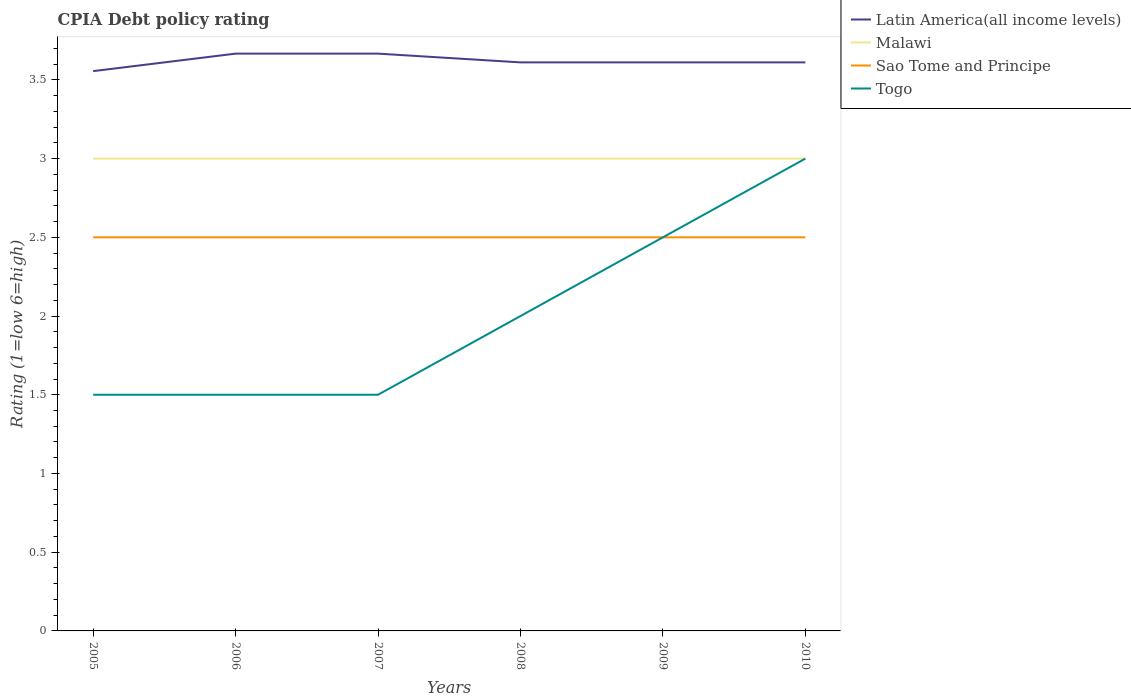Is the number of lines equal to the number of legend labels?
Provide a succinct answer. Yes. What is the total CPIA rating in Latin America(all income levels) in the graph?
Provide a short and direct response. -0.06. What is the difference between the highest and the lowest CPIA rating in Malawi?
Your answer should be compact. 0. Is the CPIA rating in Malawi strictly greater than the CPIA rating in Latin America(all income levels) over the years?
Make the answer very short. Yes. How many lines are there?
Make the answer very short. 4. How many years are there in the graph?
Provide a succinct answer. 6. What is the difference between two consecutive major ticks on the Y-axis?
Provide a short and direct response. 0.5. Are the values on the major ticks of Y-axis written in scientific E-notation?
Make the answer very short. No. Does the graph contain any zero values?
Keep it short and to the point. No. Does the graph contain grids?
Ensure brevity in your answer.  No. How many legend labels are there?
Provide a succinct answer. 4. How are the legend labels stacked?
Offer a very short reply. Vertical. What is the title of the graph?
Provide a short and direct response. CPIA Debt policy rating. What is the label or title of the Y-axis?
Provide a short and direct response. Rating (1=low 6=high). What is the Rating (1=low 6=high) of Latin America(all income levels) in 2005?
Give a very brief answer. 3.56. What is the Rating (1=low 6=high) in Sao Tome and Principe in 2005?
Offer a terse response. 2.5. What is the Rating (1=low 6=high) of Togo in 2005?
Offer a very short reply. 1.5. What is the Rating (1=low 6=high) of Latin America(all income levels) in 2006?
Provide a succinct answer. 3.67. What is the Rating (1=low 6=high) of Sao Tome and Principe in 2006?
Provide a short and direct response. 2.5. What is the Rating (1=low 6=high) of Togo in 2006?
Your answer should be compact. 1.5. What is the Rating (1=low 6=high) in Latin America(all income levels) in 2007?
Make the answer very short. 3.67. What is the Rating (1=low 6=high) of Malawi in 2007?
Provide a succinct answer. 3. What is the Rating (1=low 6=high) of Togo in 2007?
Make the answer very short. 1.5. What is the Rating (1=low 6=high) of Latin America(all income levels) in 2008?
Your answer should be compact. 3.61. What is the Rating (1=low 6=high) of Sao Tome and Principe in 2008?
Give a very brief answer. 2.5. What is the Rating (1=low 6=high) of Latin America(all income levels) in 2009?
Offer a very short reply. 3.61. What is the Rating (1=low 6=high) of Togo in 2009?
Keep it short and to the point. 2.5. What is the Rating (1=low 6=high) in Latin America(all income levels) in 2010?
Your response must be concise. 3.61. What is the Rating (1=low 6=high) of Sao Tome and Principe in 2010?
Provide a short and direct response. 2.5. What is the Rating (1=low 6=high) in Togo in 2010?
Your answer should be compact. 3. Across all years, what is the maximum Rating (1=low 6=high) in Latin America(all income levels)?
Give a very brief answer. 3.67. Across all years, what is the maximum Rating (1=low 6=high) of Malawi?
Your response must be concise. 3. Across all years, what is the minimum Rating (1=low 6=high) in Latin America(all income levels)?
Keep it short and to the point. 3.56. Across all years, what is the minimum Rating (1=low 6=high) of Malawi?
Make the answer very short. 3. Across all years, what is the minimum Rating (1=low 6=high) of Togo?
Ensure brevity in your answer.  1.5. What is the total Rating (1=low 6=high) of Latin America(all income levels) in the graph?
Ensure brevity in your answer.  21.72. What is the total Rating (1=low 6=high) of Malawi in the graph?
Provide a short and direct response. 18. What is the total Rating (1=low 6=high) of Sao Tome and Principe in the graph?
Offer a very short reply. 15. What is the difference between the Rating (1=low 6=high) of Latin America(all income levels) in 2005 and that in 2006?
Your response must be concise. -0.11. What is the difference between the Rating (1=low 6=high) in Latin America(all income levels) in 2005 and that in 2007?
Offer a terse response. -0.11. What is the difference between the Rating (1=low 6=high) in Malawi in 2005 and that in 2007?
Keep it short and to the point. 0. What is the difference between the Rating (1=low 6=high) of Sao Tome and Principe in 2005 and that in 2007?
Keep it short and to the point. 0. What is the difference between the Rating (1=low 6=high) of Togo in 2005 and that in 2007?
Keep it short and to the point. 0. What is the difference between the Rating (1=low 6=high) in Latin America(all income levels) in 2005 and that in 2008?
Give a very brief answer. -0.06. What is the difference between the Rating (1=low 6=high) in Sao Tome and Principe in 2005 and that in 2008?
Give a very brief answer. 0. What is the difference between the Rating (1=low 6=high) in Latin America(all income levels) in 2005 and that in 2009?
Your response must be concise. -0.06. What is the difference between the Rating (1=low 6=high) in Malawi in 2005 and that in 2009?
Offer a very short reply. 0. What is the difference between the Rating (1=low 6=high) of Sao Tome and Principe in 2005 and that in 2009?
Provide a short and direct response. 0. What is the difference between the Rating (1=low 6=high) in Latin America(all income levels) in 2005 and that in 2010?
Your answer should be compact. -0.06. What is the difference between the Rating (1=low 6=high) in Malawi in 2005 and that in 2010?
Your answer should be very brief. 0. What is the difference between the Rating (1=low 6=high) of Sao Tome and Principe in 2005 and that in 2010?
Keep it short and to the point. 0. What is the difference between the Rating (1=low 6=high) of Latin America(all income levels) in 2006 and that in 2007?
Give a very brief answer. 0. What is the difference between the Rating (1=low 6=high) in Sao Tome and Principe in 2006 and that in 2007?
Offer a very short reply. 0. What is the difference between the Rating (1=low 6=high) in Latin America(all income levels) in 2006 and that in 2008?
Your response must be concise. 0.06. What is the difference between the Rating (1=low 6=high) of Malawi in 2006 and that in 2008?
Offer a very short reply. 0. What is the difference between the Rating (1=low 6=high) of Latin America(all income levels) in 2006 and that in 2009?
Ensure brevity in your answer.  0.06. What is the difference between the Rating (1=low 6=high) of Latin America(all income levels) in 2006 and that in 2010?
Offer a very short reply. 0.06. What is the difference between the Rating (1=low 6=high) in Malawi in 2006 and that in 2010?
Make the answer very short. 0. What is the difference between the Rating (1=low 6=high) of Sao Tome and Principe in 2006 and that in 2010?
Provide a short and direct response. 0. What is the difference between the Rating (1=low 6=high) in Latin America(all income levels) in 2007 and that in 2008?
Offer a very short reply. 0.06. What is the difference between the Rating (1=low 6=high) of Malawi in 2007 and that in 2008?
Provide a short and direct response. 0. What is the difference between the Rating (1=low 6=high) in Sao Tome and Principe in 2007 and that in 2008?
Provide a succinct answer. 0. What is the difference between the Rating (1=low 6=high) of Togo in 2007 and that in 2008?
Provide a short and direct response. -0.5. What is the difference between the Rating (1=low 6=high) in Latin America(all income levels) in 2007 and that in 2009?
Make the answer very short. 0.06. What is the difference between the Rating (1=low 6=high) in Togo in 2007 and that in 2009?
Your answer should be compact. -1. What is the difference between the Rating (1=low 6=high) in Latin America(all income levels) in 2007 and that in 2010?
Your response must be concise. 0.06. What is the difference between the Rating (1=low 6=high) in Malawi in 2008 and that in 2009?
Offer a terse response. 0. What is the difference between the Rating (1=low 6=high) of Sao Tome and Principe in 2008 and that in 2009?
Your response must be concise. 0. What is the difference between the Rating (1=low 6=high) of Togo in 2008 and that in 2009?
Offer a terse response. -0.5. What is the difference between the Rating (1=low 6=high) in Latin America(all income levels) in 2008 and that in 2010?
Keep it short and to the point. 0. What is the difference between the Rating (1=low 6=high) in Malawi in 2008 and that in 2010?
Your answer should be compact. 0. What is the difference between the Rating (1=low 6=high) in Sao Tome and Principe in 2008 and that in 2010?
Provide a succinct answer. 0. What is the difference between the Rating (1=low 6=high) in Togo in 2008 and that in 2010?
Offer a terse response. -1. What is the difference between the Rating (1=low 6=high) of Latin America(all income levels) in 2009 and that in 2010?
Provide a succinct answer. 0. What is the difference between the Rating (1=low 6=high) of Malawi in 2009 and that in 2010?
Make the answer very short. 0. What is the difference between the Rating (1=low 6=high) of Latin America(all income levels) in 2005 and the Rating (1=low 6=high) of Malawi in 2006?
Ensure brevity in your answer.  0.56. What is the difference between the Rating (1=low 6=high) in Latin America(all income levels) in 2005 and the Rating (1=low 6=high) in Sao Tome and Principe in 2006?
Provide a short and direct response. 1.06. What is the difference between the Rating (1=low 6=high) in Latin America(all income levels) in 2005 and the Rating (1=low 6=high) in Togo in 2006?
Keep it short and to the point. 2.06. What is the difference between the Rating (1=low 6=high) in Malawi in 2005 and the Rating (1=low 6=high) in Sao Tome and Principe in 2006?
Keep it short and to the point. 0.5. What is the difference between the Rating (1=low 6=high) of Malawi in 2005 and the Rating (1=low 6=high) of Togo in 2006?
Give a very brief answer. 1.5. What is the difference between the Rating (1=low 6=high) of Latin America(all income levels) in 2005 and the Rating (1=low 6=high) of Malawi in 2007?
Your answer should be very brief. 0.56. What is the difference between the Rating (1=low 6=high) in Latin America(all income levels) in 2005 and the Rating (1=low 6=high) in Sao Tome and Principe in 2007?
Offer a terse response. 1.06. What is the difference between the Rating (1=low 6=high) in Latin America(all income levels) in 2005 and the Rating (1=low 6=high) in Togo in 2007?
Offer a very short reply. 2.06. What is the difference between the Rating (1=low 6=high) of Latin America(all income levels) in 2005 and the Rating (1=low 6=high) of Malawi in 2008?
Provide a short and direct response. 0.56. What is the difference between the Rating (1=low 6=high) of Latin America(all income levels) in 2005 and the Rating (1=low 6=high) of Sao Tome and Principe in 2008?
Offer a very short reply. 1.06. What is the difference between the Rating (1=low 6=high) of Latin America(all income levels) in 2005 and the Rating (1=low 6=high) of Togo in 2008?
Your answer should be compact. 1.56. What is the difference between the Rating (1=low 6=high) of Malawi in 2005 and the Rating (1=low 6=high) of Togo in 2008?
Your answer should be very brief. 1. What is the difference between the Rating (1=low 6=high) in Latin America(all income levels) in 2005 and the Rating (1=low 6=high) in Malawi in 2009?
Provide a succinct answer. 0.56. What is the difference between the Rating (1=low 6=high) in Latin America(all income levels) in 2005 and the Rating (1=low 6=high) in Sao Tome and Principe in 2009?
Your response must be concise. 1.06. What is the difference between the Rating (1=low 6=high) of Latin America(all income levels) in 2005 and the Rating (1=low 6=high) of Togo in 2009?
Your response must be concise. 1.06. What is the difference between the Rating (1=low 6=high) in Malawi in 2005 and the Rating (1=low 6=high) in Togo in 2009?
Make the answer very short. 0.5. What is the difference between the Rating (1=low 6=high) of Latin America(all income levels) in 2005 and the Rating (1=low 6=high) of Malawi in 2010?
Give a very brief answer. 0.56. What is the difference between the Rating (1=low 6=high) of Latin America(all income levels) in 2005 and the Rating (1=low 6=high) of Sao Tome and Principe in 2010?
Give a very brief answer. 1.06. What is the difference between the Rating (1=low 6=high) of Latin America(all income levels) in 2005 and the Rating (1=low 6=high) of Togo in 2010?
Ensure brevity in your answer.  0.56. What is the difference between the Rating (1=low 6=high) of Malawi in 2005 and the Rating (1=low 6=high) of Sao Tome and Principe in 2010?
Offer a very short reply. 0.5. What is the difference between the Rating (1=low 6=high) of Sao Tome and Principe in 2005 and the Rating (1=low 6=high) of Togo in 2010?
Provide a succinct answer. -0.5. What is the difference between the Rating (1=low 6=high) of Latin America(all income levels) in 2006 and the Rating (1=low 6=high) of Sao Tome and Principe in 2007?
Offer a terse response. 1.17. What is the difference between the Rating (1=low 6=high) in Latin America(all income levels) in 2006 and the Rating (1=low 6=high) in Togo in 2007?
Make the answer very short. 2.17. What is the difference between the Rating (1=low 6=high) of Sao Tome and Principe in 2006 and the Rating (1=low 6=high) of Togo in 2007?
Your answer should be compact. 1. What is the difference between the Rating (1=low 6=high) of Latin America(all income levels) in 2006 and the Rating (1=low 6=high) of Malawi in 2008?
Ensure brevity in your answer.  0.67. What is the difference between the Rating (1=low 6=high) of Latin America(all income levels) in 2006 and the Rating (1=low 6=high) of Sao Tome and Principe in 2008?
Keep it short and to the point. 1.17. What is the difference between the Rating (1=low 6=high) of Latin America(all income levels) in 2006 and the Rating (1=low 6=high) of Togo in 2009?
Your response must be concise. 1.17. What is the difference between the Rating (1=low 6=high) of Malawi in 2006 and the Rating (1=low 6=high) of Sao Tome and Principe in 2009?
Ensure brevity in your answer.  0.5. What is the difference between the Rating (1=low 6=high) of Malawi in 2006 and the Rating (1=low 6=high) of Togo in 2009?
Offer a very short reply. 0.5. What is the difference between the Rating (1=low 6=high) of Latin America(all income levels) in 2006 and the Rating (1=low 6=high) of Sao Tome and Principe in 2010?
Offer a very short reply. 1.17. What is the difference between the Rating (1=low 6=high) in Sao Tome and Principe in 2006 and the Rating (1=low 6=high) in Togo in 2010?
Your response must be concise. -0.5. What is the difference between the Rating (1=low 6=high) in Malawi in 2007 and the Rating (1=low 6=high) in Sao Tome and Principe in 2008?
Your response must be concise. 0.5. What is the difference between the Rating (1=low 6=high) of Malawi in 2007 and the Rating (1=low 6=high) of Togo in 2008?
Make the answer very short. 1. What is the difference between the Rating (1=low 6=high) in Latin America(all income levels) in 2007 and the Rating (1=low 6=high) in Malawi in 2009?
Keep it short and to the point. 0.67. What is the difference between the Rating (1=low 6=high) in Latin America(all income levels) in 2007 and the Rating (1=low 6=high) in Togo in 2009?
Offer a terse response. 1.17. What is the difference between the Rating (1=low 6=high) of Malawi in 2007 and the Rating (1=low 6=high) of Sao Tome and Principe in 2009?
Give a very brief answer. 0.5. What is the difference between the Rating (1=low 6=high) of Malawi in 2007 and the Rating (1=low 6=high) of Togo in 2009?
Your response must be concise. 0.5. What is the difference between the Rating (1=low 6=high) in Sao Tome and Principe in 2007 and the Rating (1=low 6=high) in Togo in 2009?
Your answer should be compact. 0. What is the difference between the Rating (1=low 6=high) of Latin America(all income levels) in 2007 and the Rating (1=low 6=high) of Malawi in 2010?
Give a very brief answer. 0.67. What is the difference between the Rating (1=low 6=high) of Latin America(all income levels) in 2007 and the Rating (1=low 6=high) of Sao Tome and Principe in 2010?
Your response must be concise. 1.17. What is the difference between the Rating (1=low 6=high) of Latin America(all income levels) in 2007 and the Rating (1=low 6=high) of Togo in 2010?
Your response must be concise. 0.67. What is the difference between the Rating (1=low 6=high) in Latin America(all income levels) in 2008 and the Rating (1=low 6=high) in Malawi in 2009?
Offer a terse response. 0.61. What is the difference between the Rating (1=low 6=high) in Latin America(all income levels) in 2008 and the Rating (1=low 6=high) in Sao Tome and Principe in 2009?
Make the answer very short. 1.11. What is the difference between the Rating (1=low 6=high) in Latin America(all income levels) in 2008 and the Rating (1=low 6=high) in Togo in 2009?
Offer a terse response. 1.11. What is the difference between the Rating (1=low 6=high) in Malawi in 2008 and the Rating (1=low 6=high) in Togo in 2009?
Make the answer very short. 0.5. What is the difference between the Rating (1=low 6=high) of Sao Tome and Principe in 2008 and the Rating (1=low 6=high) of Togo in 2009?
Provide a succinct answer. 0. What is the difference between the Rating (1=low 6=high) of Latin America(all income levels) in 2008 and the Rating (1=low 6=high) of Malawi in 2010?
Your answer should be very brief. 0.61. What is the difference between the Rating (1=low 6=high) in Latin America(all income levels) in 2008 and the Rating (1=low 6=high) in Togo in 2010?
Provide a short and direct response. 0.61. What is the difference between the Rating (1=low 6=high) of Malawi in 2008 and the Rating (1=low 6=high) of Sao Tome and Principe in 2010?
Offer a very short reply. 0.5. What is the difference between the Rating (1=low 6=high) of Sao Tome and Principe in 2008 and the Rating (1=low 6=high) of Togo in 2010?
Keep it short and to the point. -0.5. What is the difference between the Rating (1=low 6=high) in Latin America(all income levels) in 2009 and the Rating (1=low 6=high) in Malawi in 2010?
Offer a terse response. 0.61. What is the difference between the Rating (1=low 6=high) in Latin America(all income levels) in 2009 and the Rating (1=low 6=high) in Togo in 2010?
Your answer should be very brief. 0.61. What is the difference between the Rating (1=low 6=high) in Malawi in 2009 and the Rating (1=low 6=high) in Sao Tome and Principe in 2010?
Your response must be concise. 0.5. What is the average Rating (1=low 6=high) in Latin America(all income levels) per year?
Make the answer very short. 3.62. What is the average Rating (1=low 6=high) in Malawi per year?
Give a very brief answer. 3. In the year 2005, what is the difference between the Rating (1=low 6=high) in Latin America(all income levels) and Rating (1=low 6=high) in Malawi?
Provide a succinct answer. 0.56. In the year 2005, what is the difference between the Rating (1=low 6=high) of Latin America(all income levels) and Rating (1=low 6=high) of Sao Tome and Principe?
Ensure brevity in your answer.  1.06. In the year 2005, what is the difference between the Rating (1=low 6=high) in Latin America(all income levels) and Rating (1=low 6=high) in Togo?
Ensure brevity in your answer.  2.06. In the year 2005, what is the difference between the Rating (1=low 6=high) of Malawi and Rating (1=low 6=high) of Sao Tome and Principe?
Offer a very short reply. 0.5. In the year 2005, what is the difference between the Rating (1=low 6=high) in Sao Tome and Principe and Rating (1=low 6=high) in Togo?
Your response must be concise. 1. In the year 2006, what is the difference between the Rating (1=low 6=high) in Latin America(all income levels) and Rating (1=low 6=high) in Malawi?
Offer a terse response. 0.67. In the year 2006, what is the difference between the Rating (1=low 6=high) in Latin America(all income levels) and Rating (1=low 6=high) in Sao Tome and Principe?
Ensure brevity in your answer.  1.17. In the year 2006, what is the difference between the Rating (1=low 6=high) in Latin America(all income levels) and Rating (1=low 6=high) in Togo?
Your response must be concise. 2.17. In the year 2006, what is the difference between the Rating (1=low 6=high) in Malawi and Rating (1=low 6=high) in Togo?
Keep it short and to the point. 1.5. In the year 2007, what is the difference between the Rating (1=low 6=high) in Latin America(all income levels) and Rating (1=low 6=high) in Togo?
Offer a very short reply. 2.17. In the year 2007, what is the difference between the Rating (1=low 6=high) of Sao Tome and Principe and Rating (1=low 6=high) of Togo?
Offer a very short reply. 1. In the year 2008, what is the difference between the Rating (1=low 6=high) in Latin America(all income levels) and Rating (1=low 6=high) in Malawi?
Ensure brevity in your answer.  0.61. In the year 2008, what is the difference between the Rating (1=low 6=high) of Latin America(all income levels) and Rating (1=low 6=high) of Sao Tome and Principe?
Offer a terse response. 1.11. In the year 2008, what is the difference between the Rating (1=low 6=high) of Latin America(all income levels) and Rating (1=low 6=high) of Togo?
Offer a terse response. 1.61. In the year 2009, what is the difference between the Rating (1=low 6=high) of Latin America(all income levels) and Rating (1=low 6=high) of Malawi?
Offer a very short reply. 0.61. In the year 2009, what is the difference between the Rating (1=low 6=high) in Latin America(all income levels) and Rating (1=low 6=high) in Togo?
Ensure brevity in your answer.  1.11. In the year 2009, what is the difference between the Rating (1=low 6=high) of Malawi and Rating (1=low 6=high) of Sao Tome and Principe?
Offer a very short reply. 0.5. In the year 2009, what is the difference between the Rating (1=low 6=high) in Malawi and Rating (1=low 6=high) in Togo?
Make the answer very short. 0.5. In the year 2009, what is the difference between the Rating (1=low 6=high) of Sao Tome and Principe and Rating (1=low 6=high) of Togo?
Ensure brevity in your answer.  0. In the year 2010, what is the difference between the Rating (1=low 6=high) of Latin America(all income levels) and Rating (1=low 6=high) of Malawi?
Provide a short and direct response. 0.61. In the year 2010, what is the difference between the Rating (1=low 6=high) of Latin America(all income levels) and Rating (1=low 6=high) of Togo?
Your answer should be very brief. 0.61. In the year 2010, what is the difference between the Rating (1=low 6=high) of Malawi and Rating (1=low 6=high) of Togo?
Offer a terse response. 0. In the year 2010, what is the difference between the Rating (1=low 6=high) of Sao Tome and Principe and Rating (1=low 6=high) of Togo?
Ensure brevity in your answer.  -0.5. What is the ratio of the Rating (1=low 6=high) in Latin America(all income levels) in 2005 to that in 2006?
Make the answer very short. 0.97. What is the ratio of the Rating (1=low 6=high) of Togo in 2005 to that in 2006?
Your answer should be very brief. 1. What is the ratio of the Rating (1=low 6=high) of Latin America(all income levels) in 2005 to that in 2007?
Provide a succinct answer. 0.97. What is the ratio of the Rating (1=low 6=high) in Malawi in 2005 to that in 2007?
Provide a short and direct response. 1. What is the ratio of the Rating (1=low 6=high) of Togo in 2005 to that in 2007?
Give a very brief answer. 1. What is the ratio of the Rating (1=low 6=high) of Latin America(all income levels) in 2005 to that in 2008?
Ensure brevity in your answer.  0.98. What is the ratio of the Rating (1=low 6=high) of Sao Tome and Principe in 2005 to that in 2008?
Keep it short and to the point. 1. What is the ratio of the Rating (1=low 6=high) in Togo in 2005 to that in 2008?
Your response must be concise. 0.75. What is the ratio of the Rating (1=low 6=high) in Latin America(all income levels) in 2005 to that in 2009?
Ensure brevity in your answer.  0.98. What is the ratio of the Rating (1=low 6=high) of Sao Tome and Principe in 2005 to that in 2009?
Your response must be concise. 1. What is the ratio of the Rating (1=low 6=high) in Latin America(all income levels) in 2005 to that in 2010?
Provide a succinct answer. 0.98. What is the ratio of the Rating (1=low 6=high) of Sao Tome and Principe in 2005 to that in 2010?
Provide a short and direct response. 1. What is the ratio of the Rating (1=low 6=high) in Togo in 2005 to that in 2010?
Ensure brevity in your answer.  0.5. What is the ratio of the Rating (1=low 6=high) of Malawi in 2006 to that in 2007?
Provide a short and direct response. 1. What is the ratio of the Rating (1=low 6=high) in Togo in 2006 to that in 2007?
Provide a short and direct response. 1. What is the ratio of the Rating (1=low 6=high) of Latin America(all income levels) in 2006 to that in 2008?
Your response must be concise. 1.02. What is the ratio of the Rating (1=low 6=high) in Malawi in 2006 to that in 2008?
Provide a succinct answer. 1. What is the ratio of the Rating (1=low 6=high) in Sao Tome and Principe in 2006 to that in 2008?
Your response must be concise. 1. What is the ratio of the Rating (1=low 6=high) of Togo in 2006 to that in 2008?
Give a very brief answer. 0.75. What is the ratio of the Rating (1=low 6=high) of Latin America(all income levels) in 2006 to that in 2009?
Your answer should be compact. 1.02. What is the ratio of the Rating (1=low 6=high) in Malawi in 2006 to that in 2009?
Offer a very short reply. 1. What is the ratio of the Rating (1=low 6=high) in Sao Tome and Principe in 2006 to that in 2009?
Provide a short and direct response. 1. What is the ratio of the Rating (1=low 6=high) in Latin America(all income levels) in 2006 to that in 2010?
Give a very brief answer. 1.02. What is the ratio of the Rating (1=low 6=high) in Malawi in 2006 to that in 2010?
Your answer should be compact. 1. What is the ratio of the Rating (1=low 6=high) in Sao Tome and Principe in 2006 to that in 2010?
Make the answer very short. 1. What is the ratio of the Rating (1=low 6=high) of Latin America(all income levels) in 2007 to that in 2008?
Keep it short and to the point. 1.02. What is the ratio of the Rating (1=low 6=high) in Sao Tome and Principe in 2007 to that in 2008?
Ensure brevity in your answer.  1. What is the ratio of the Rating (1=low 6=high) of Latin America(all income levels) in 2007 to that in 2009?
Provide a succinct answer. 1.02. What is the ratio of the Rating (1=low 6=high) of Malawi in 2007 to that in 2009?
Offer a very short reply. 1. What is the ratio of the Rating (1=low 6=high) in Togo in 2007 to that in 2009?
Offer a very short reply. 0.6. What is the ratio of the Rating (1=low 6=high) of Latin America(all income levels) in 2007 to that in 2010?
Offer a terse response. 1.02. What is the ratio of the Rating (1=low 6=high) in Latin America(all income levels) in 2008 to that in 2009?
Make the answer very short. 1. What is the ratio of the Rating (1=low 6=high) of Togo in 2008 to that in 2009?
Provide a succinct answer. 0.8. What is the ratio of the Rating (1=low 6=high) in Latin America(all income levels) in 2008 to that in 2010?
Your answer should be compact. 1. What is the ratio of the Rating (1=low 6=high) in Malawi in 2008 to that in 2010?
Offer a very short reply. 1. What is the ratio of the Rating (1=low 6=high) in Sao Tome and Principe in 2008 to that in 2010?
Offer a terse response. 1. What is the ratio of the Rating (1=low 6=high) of Togo in 2008 to that in 2010?
Provide a succinct answer. 0.67. What is the ratio of the Rating (1=low 6=high) in Sao Tome and Principe in 2009 to that in 2010?
Provide a short and direct response. 1. What is the difference between the highest and the second highest Rating (1=low 6=high) of Togo?
Ensure brevity in your answer.  0.5. What is the difference between the highest and the lowest Rating (1=low 6=high) in Latin America(all income levels)?
Your answer should be compact. 0.11. What is the difference between the highest and the lowest Rating (1=low 6=high) in Sao Tome and Principe?
Keep it short and to the point. 0. What is the difference between the highest and the lowest Rating (1=low 6=high) in Togo?
Keep it short and to the point. 1.5. 